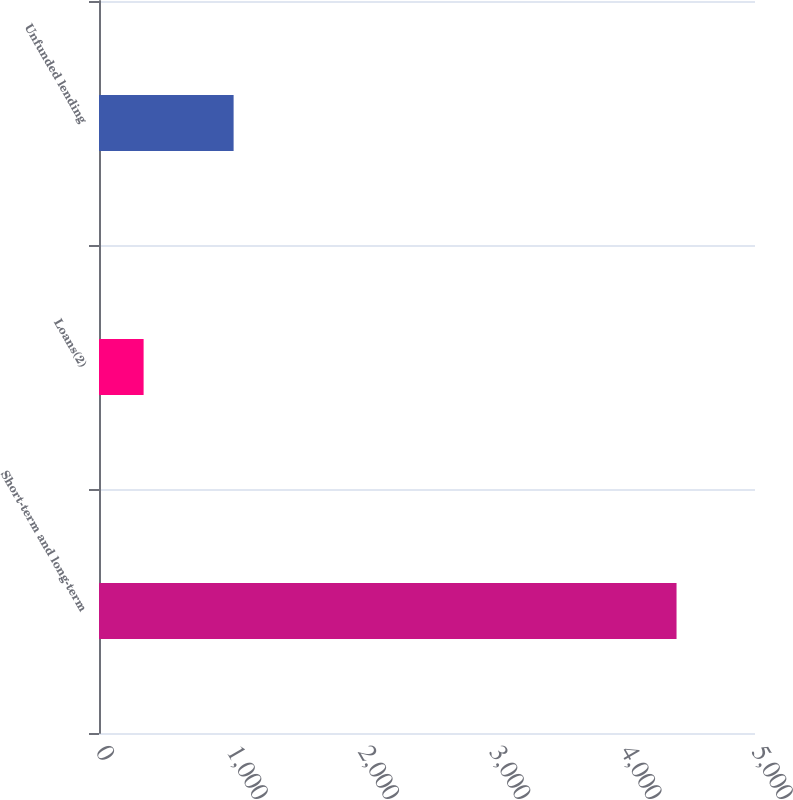<chart> <loc_0><loc_0><loc_500><loc_500><bar_chart><fcel>Short-term and long-term<fcel>Loans(2)<fcel>Unfunded lending<nl><fcel>4402<fcel>340<fcel>1026<nl></chart> 